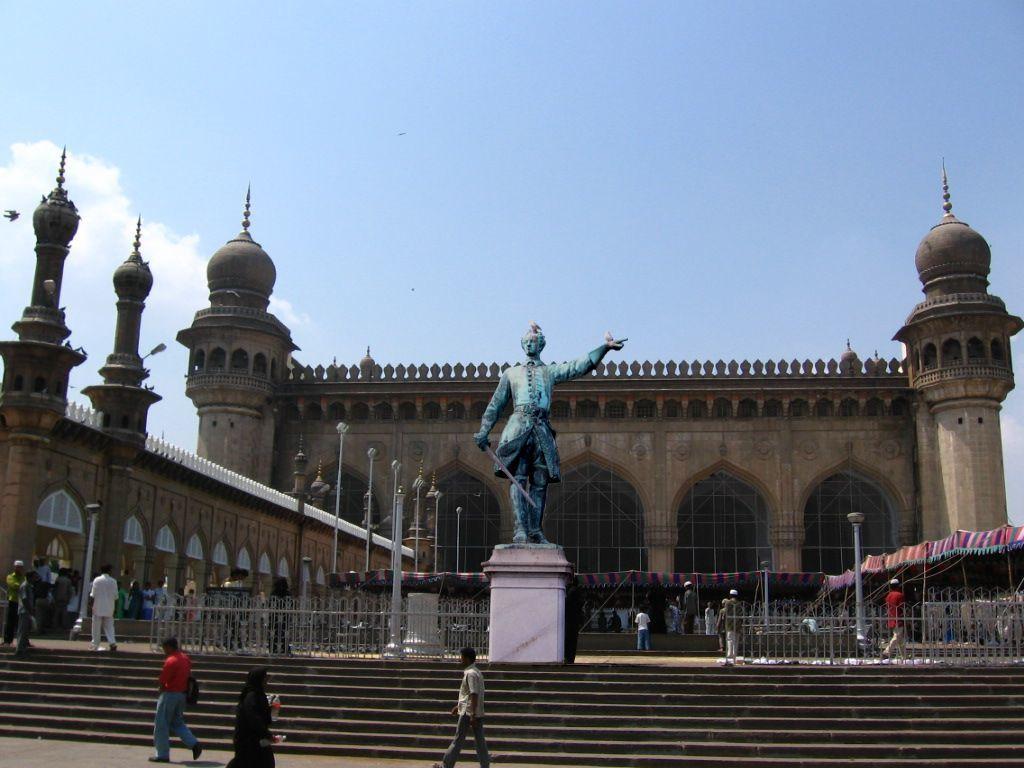Can you describe this image briefly? Sky is in blue color. Here we can see clouds. In-front of this building there are light poles, fence, tent, people and statue. Beside these people we can see steps. 